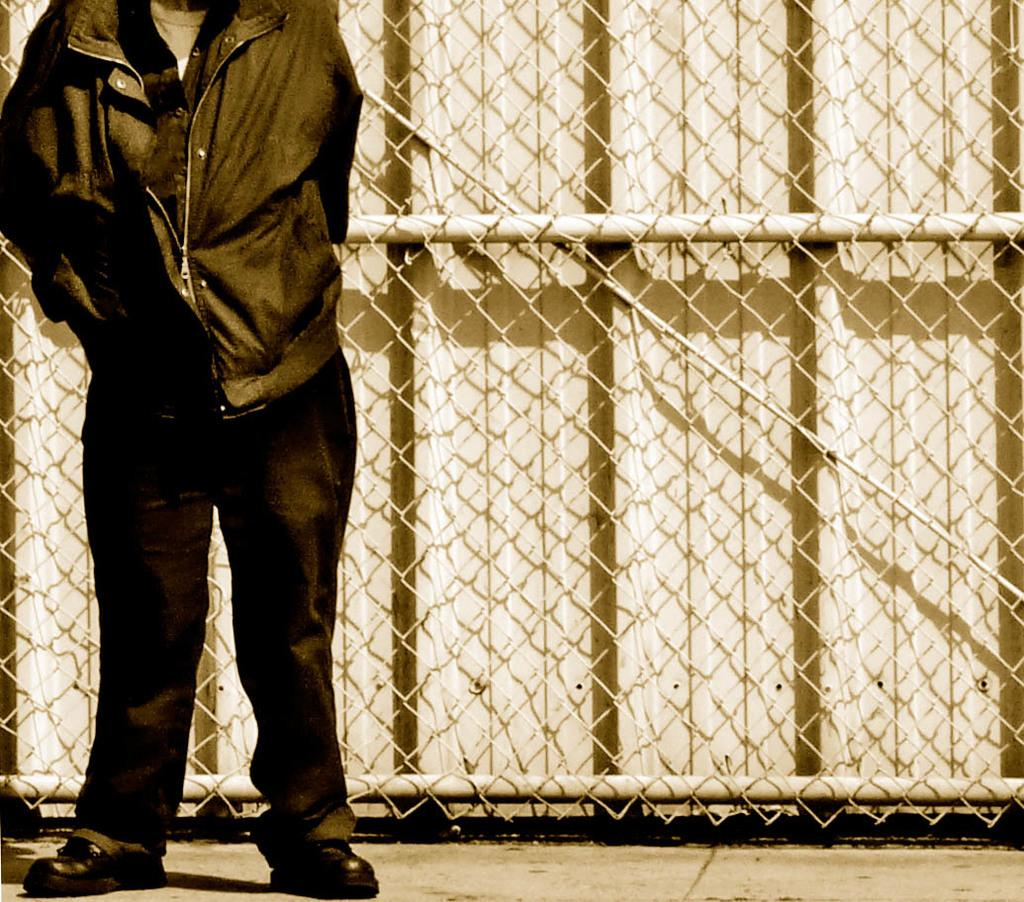What is present in the image? There is a person in the image. Can you describe the person's appearance in the image? The person's face is not visible in the image. What is the person standing in front of? The person is standing in front of a fencing. What type of beetle can be seen crawling on the person's shoulder in the image? There is no beetle present on the person's shoulder in the image. What kind of music is the band playing in the background of the image? There is no band present in the background of the image. 